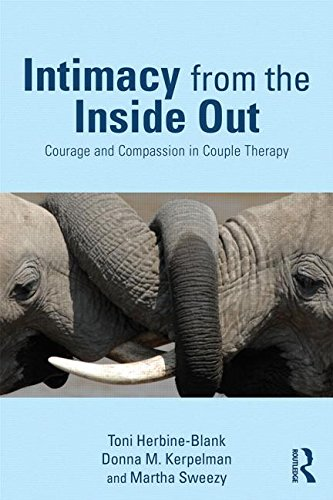What is the title of this book? The title of the book is 'Intimacy from the Inside Out: Courage and Compassion in Couple Therapy,' which explores therapeutic methods for enhancing intimacy in relationships. 